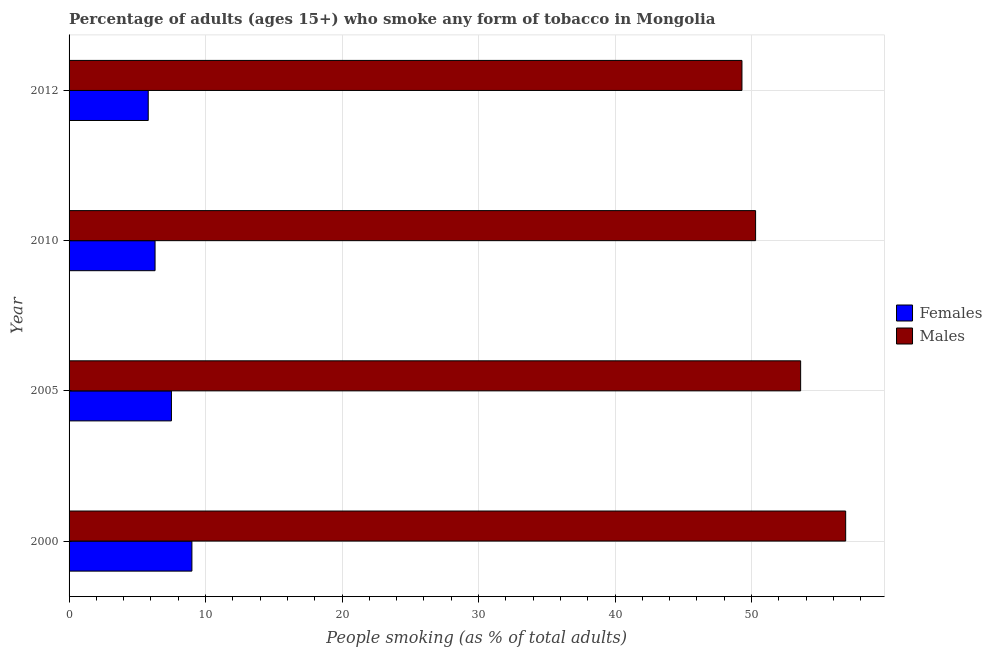How many different coloured bars are there?
Your answer should be very brief. 2. How many groups of bars are there?
Offer a very short reply. 4. Are the number of bars per tick equal to the number of legend labels?
Give a very brief answer. Yes. Are the number of bars on each tick of the Y-axis equal?
Provide a short and direct response. Yes. How many bars are there on the 3rd tick from the bottom?
Your answer should be compact. 2. What is the label of the 2nd group of bars from the top?
Provide a succinct answer. 2010. Across all years, what is the maximum percentage of females who smoke?
Ensure brevity in your answer.  9. Across all years, what is the minimum percentage of females who smoke?
Provide a succinct answer. 5.8. In which year was the percentage of females who smoke maximum?
Keep it short and to the point. 2000. What is the total percentage of males who smoke in the graph?
Make the answer very short. 210.1. What is the difference between the percentage of males who smoke in 2005 and that in 2010?
Give a very brief answer. 3.3. What is the difference between the percentage of males who smoke in 2000 and the percentage of females who smoke in 2012?
Give a very brief answer. 51.1. What is the average percentage of males who smoke per year?
Your answer should be very brief. 52.52. In how many years, is the percentage of males who smoke greater than 4 %?
Make the answer very short. 4. What is the ratio of the percentage of males who smoke in 2000 to that in 2005?
Make the answer very short. 1.06. What is the difference between the highest and the second highest percentage of females who smoke?
Ensure brevity in your answer.  1.5. What is the difference between the highest and the lowest percentage of males who smoke?
Keep it short and to the point. 7.6. Is the sum of the percentage of males who smoke in 2005 and 2010 greater than the maximum percentage of females who smoke across all years?
Ensure brevity in your answer.  Yes. What does the 1st bar from the top in 2012 represents?
Offer a very short reply. Males. What does the 1st bar from the bottom in 2000 represents?
Provide a succinct answer. Females. Are all the bars in the graph horizontal?
Offer a very short reply. Yes. How many years are there in the graph?
Offer a terse response. 4. What is the difference between two consecutive major ticks on the X-axis?
Your answer should be compact. 10. Are the values on the major ticks of X-axis written in scientific E-notation?
Ensure brevity in your answer.  No. Does the graph contain any zero values?
Your answer should be compact. No. How many legend labels are there?
Provide a succinct answer. 2. What is the title of the graph?
Provide a succinct answer. Percentage of adults (ages 15+) who smoke any form of tobacco in Mongolia. Does "Revenue" appear as one of the legend labels in the graph?
Keep it short and to the point. No. What is the label or title of the X-axis?
Your answer should be very brief. People smoking (as % of total adults). What is the label or title of the Y-axis?
Keep it short and to the point. Year. What is the People smoking (as % of total adults) of Females in 2000?
Keep it short and to the point. 9. What is the People smoking (as % of total adults) in Males in 2000?
Your answer should be very brief. 56.9. What is the People smoking (as % of total adults) in Males in 2005?
Make the answer very short. 53.6. What is the People smoking (as % of total adults) of Females in 2010?
Offer a terse response. 6.3. What is the People smoking (as % of total adults) in Males in 2010?
Provide a short and direct response. 50.3. What is the People smoking (as % of total adults) of Males in 2012?
Provide a succinct answer. 49.3. Across all years, what is the maximum People smoking (as % of total adults) in Females?
Your answer should be compact. 9. Across all years, what is the maximum People smoking (as % of total adults) in Males?
Keep it short and to the point. 56.9. Across all years, what is the minimum People smoking (as % of total adults) of Females?
Your response must be concise. 5.8. Across all years, what is the minimum People smoking (as % of total adults) of Males?
Your response must be concise. 49.3. What is the total People smoking (as % of total adults) of Females in the graph?
Your answer should be very brief. 28.6. What is the total People smoking (as % of total adults) of Males in the graph?
Your answer should be very brief. 210.1. What is the difference between the People smoking (as % of total adults) of Females in 2000 and that in 2005?
Keep it short and to the point. 1.5. What is the difference between the People smoking (as % of total adults) in Males in 2000 and that in 2005?
Provide a short and direct response. 3.3. What is the difference between the People smoking (as % of total adults) in Females in 2000 and that in 2010?
Keep it short and to the point. 2.7. What is the difference between the People smoking (as % of total adults) in Males in 2000 and that in 2010?
Give a very brief answer. 6.6. What is the difference between the People smoking (as % of total adults) in Females in 2000 and that in 2012?
Your answer should be very brief. 3.2. What is the difference between the People smoking (as % of total adults) of Females in 2005 and that in 2010?
Offer a very short reply. 1.2. What is the difference between the People smoking (as % of total adults) of Males in 2005 and that in 2010?
Give a very brief answer. 3.3. What is the difference between the People smoking (as % of total adults) of Females in 2005 and that in 2012?
Offer a terse response. 1.7. What is the difference between the People smoking (as % of total adults) of Males in 2005 and that in 2012?
Your answer should be very brief. 4.3. What is the difference between the People smoking (as % of total adults) of Males in 2010 and that in 2012?
Offer a very short reply. 1. What is the difference between the People smoking (as % of total adults) in Females in 2000 and the People smoking (as % of total adults) in Males in 2005?
Keep it short and to the point. -44.6. What is the difference between the People smoking (as % of total adults) of Females in 2000 and the People smoking (as % of total adults) of Males in 2010?
Provide a succinct answer. -41.3. What is the difference between the People smoking (as % of total adults) of Females in 2000 and the People smoking (as % of total adults) of Males in 2012?
Offer a very short reply. -40.3. What is the difference between the People smoking (as % of total adults) of Females in 2005 and the People smoking (as % of total adults) of Males in 2010?
Ensure brevity in your answer.  -42.8. What is the difference between the People smoking (as % of total adults) in Females in 2005 and the People smoking (as % of total adults) in Males in 2012?
Keep it short and to the point. -41.8. What is the difference between the People smoking (as % of total adults) of Females in 2010 and the People smoking (as % of total adults) of Males in 2012?
Your answer should be compact. -43. What is the average People smoking (as % of total adults) in Females per year?
Offer a very short reply. 7.15. What is the average People smoking (as % of total adults) of Males per year?
Keep it short and to the point. 52.52. In the year 2000, what is the difference between the People smoking (as % of total adults) of Females and People smoking (as % of total adults) of Males?
Your response must be concise. -47.9. In the year 2005, what is the difference between the People smoking (as % of total adults) in Females and People smoking (as % of total adults) in Males?
Your answer should be very brief. -46.1. In the year 2010, what is the difference between the People smoking (as % of total adults) in Females and People smoking (as % of total adults) in Males?
Provide a succinct answer. -44. In the year 2012, what is the difference between the People smoking (as % of total adults) in Females and People smoking (as % of total adults) in Males?
Offer a very short reply. -43.5. What is the ratio of the People smoking (as % of total adults) in Females in 2000 to that in 2005?
Provide a succinct answer. 1.2. What is the ratio of the People smoking (as % of total adults) in Males in 2000 to that in 2005?
Your answer should be very brief. 1.06. What is the ratio of the People smoking (as % of total adults) in Females in 2000 to that in 2010?
Your response must be concise. 1.43. What is the ratio of the People smoking (as % of total adults) in Males in 2000 to that in 2010?
Your answer should be very brief. 1.13. What is the ratio of the People smoking (as % of total adults) of Females in 2000 to that in 2012?
Ensure brevity in your answer.  1.55. What is the ratio of the People smoking (as % of total adults) of Males in 2000 to that in 2012?
Make the answer very short. 1.15. What is the ratio of the People smoking (as % of total adults) in Females in 2005 to that in 2010?
Provide a succinct answer. 1.19. What is the ratio of the People smoking (as % of total adults) in Males in 2005 to that in 2010?
Provide a succinct answer. 1.07. What is the ratio of the People smoking (as % of total adults) in Females in 2005 to that in 2012?
Offer a very short reply. 1.29. What is the ratio of the People smoking (as % of total adults) in Males in 2005 to that in 2012?
Your answer should be compact. 1.09. What is the ratio of the People smoking (as % of total adults) in Females in 2010 to that in 2012?
Offer a very short reply. 1.09. What is the ratio of the People smoking (as % of total adults) in Males in 2010 to that in 2012?
Offer a terse response. 1.02. What is the difference between the highest and the second highest People smoking (as % of total adults) in Males?
Provide a short and direct response. 3.3. What is the difference between the highest and the lowest People smoking (as % of total adults) of Females?
Provide a succinct answer. 3.2. What is the difference between the highest and the lowest People smoking (as % of total adults) of Males?
Give a very brief answer. 7.6. 